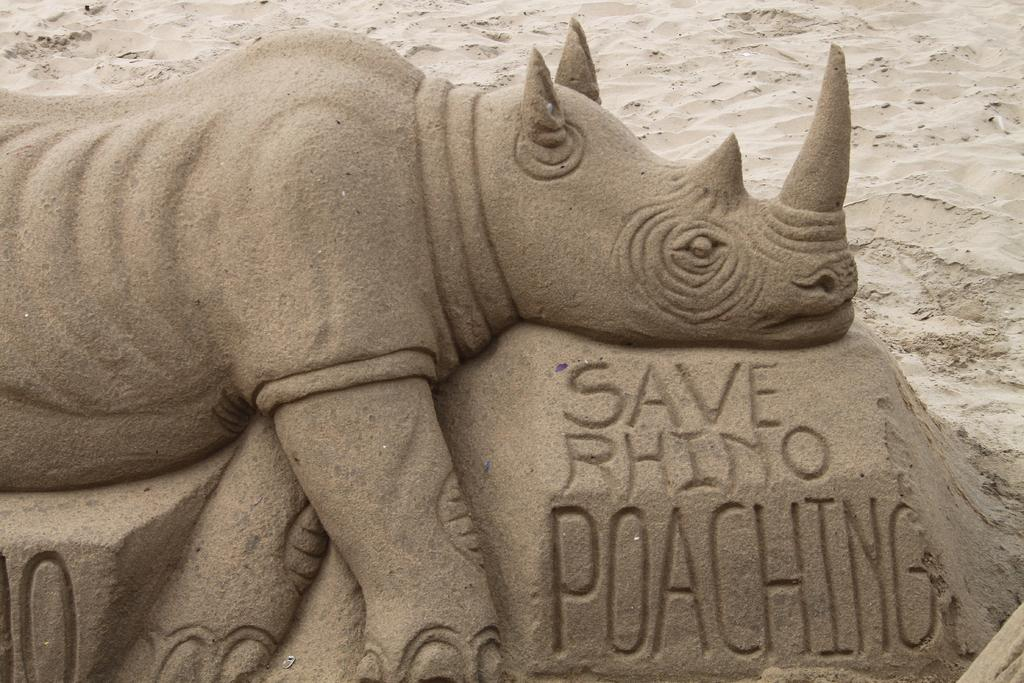What is the main subject of the sand art in the image? The main subject of the sand art in the image is a rhino. Are there any additional elements on the sand art besides the rhino? Yes, there are words on the sand art. What can be seen in the background of the image? There is sand visible in the background of the image. How many visitors are present in the image? There is no information about visitors in the image; it only features a sand art of a rhino. Can you tell me the color of the kitty in the image? There is no kitty present in the image. 